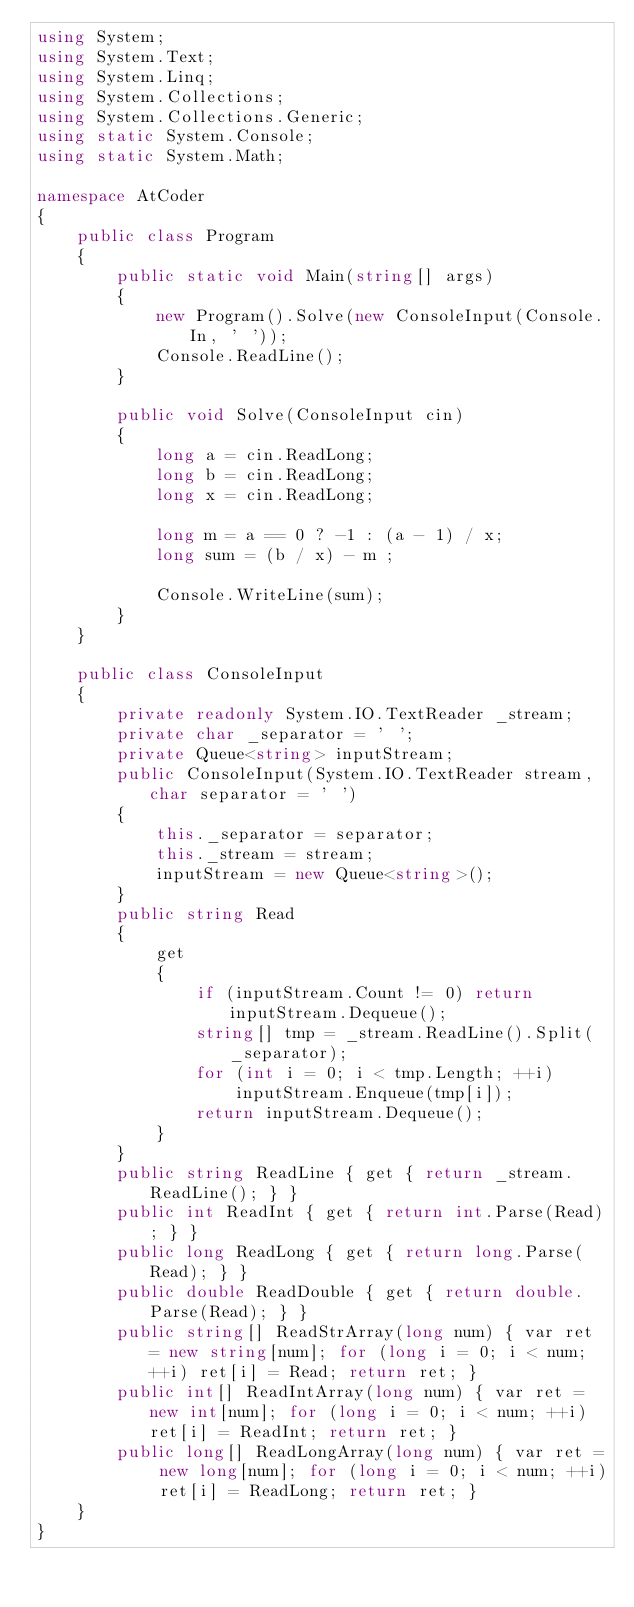Convert code to text. <code><loc_0><loc_0><loc_500><loc_500><_C#_>using System;
using System.Text;
using System.Linq;
using System.Collections;
using System.Collections.Generic;
using static System.Console;
using static System.Math;

namespace AtCoder
{
    public class Program
    {
        public static void Main(string[] args)
        {
            new Program().Solve(new ConsoleInput(Console.In, ' '));
            Console.ReadLine();
        }

        public void Solve(ConsoleInput cin)
        {
            long a = cin.ReadLong;
            long b = cin.ReadLong;
            long x = cin.ReadLong;

            long m = a == 0 ? -1 : (a - 1) / x;
            long sum = (b / x) - m ;

            Console.WriteLine(sum);
        }
    }

    public class ConsoleInput
    {
        private readonly System.IO.TextReader _stream;
        private char _separator = ' ';
        private Queue<string> inputStream;
        public ConsoleInput(System.IO.TextReader stream, char separator = ' ')
        {
            this._separator = separator;
            this._stream = stream;
            inputStream = new Queue<string>();
        }
        public string Read
        {
            get
            {
                if (inputStream.Count != 0) return inputStream.Dequeue();
                string[] tmp = _stream.ReadLine().Split(_separator);
                for (int i = 0; i < tmp.Length; ++i)
                    inputStream.Enqueue(tmp[i]);
                return inputStream.Dequeue();
            }
        }
        public string ReadLine { get { return _stream.ReadLine(); } }
        public int ReadInt { get { return int.Parse(Read); } }
        public long ReadLong { get { return long.Parse(Read); } }
        public double ReadDouble { get { return double.Parse(Read); } }
        public string[] ReadStrArray(long num) { var ret = new string[num]; for (long i = 0; i < num; ++i) ret[i] = Read; return ret; }
        public int[] ReadIntArray(long num) { var ret = new int[num]; for (long i = 0; i < num; ++i) ret[i] = ReadInt; return ret; }
        public long[] ReadLongArray(long num) { var ret = new long[num]; for (long i = 0; i < num; ++i) ret[i] = ReadLong; return ret; }
    }
}</code> 